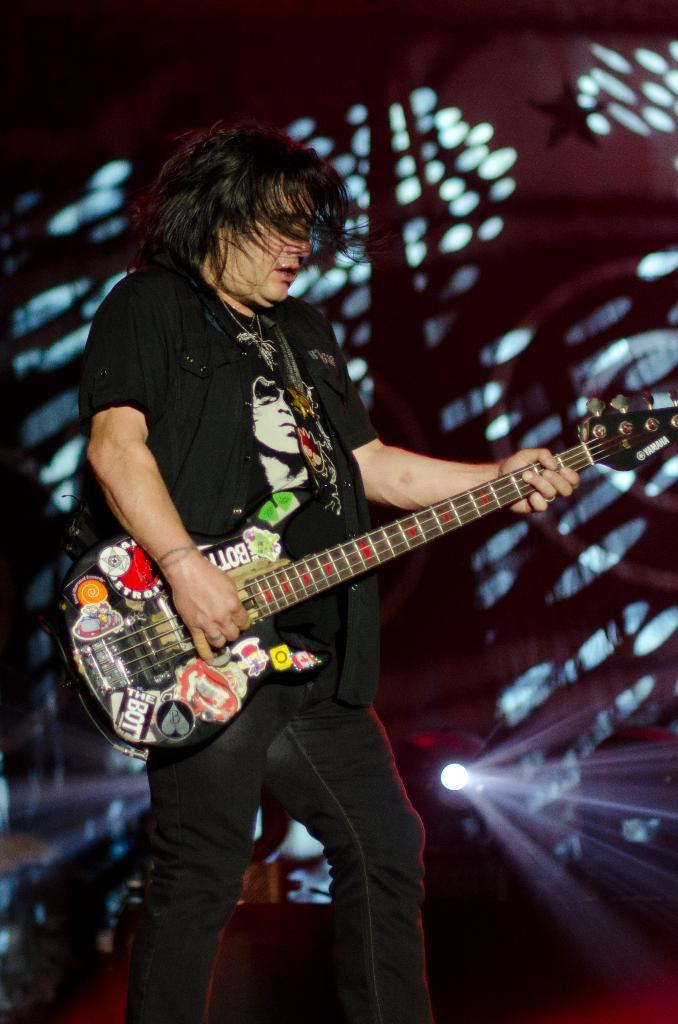Who is the person in the image? There is a man in the image. What is the man holding in the image? The man is holding a guitar. What is the man doing with the guitar? The man is playing the guitar. What color is the man's t-shirt? The man is wearing a black t-shirt. What color are the man's jeans? The man is wearing black jeans. What can be seen in the background of the image? There is light visible in the background of the image. What type of operation is the man performing on the lumber in the image? There is no lumber or operation present in the image; it features a man playing a guitar. 